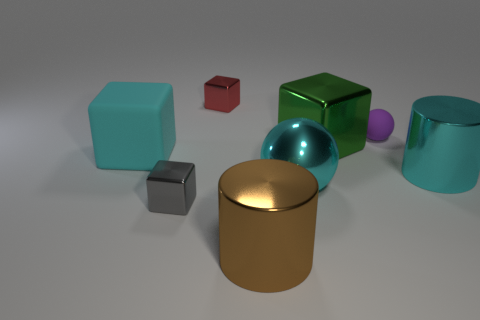What number of metallic objects are either big spheres or brown cylinders?
Ensure brevity in your answer.  2. Does the gray thing have the same material as the cyan sphere?
Ensure brevity in your answer.  Yes. What material is the large cube in front of the metal cube that is right of the red block?
Ensure brevity in your answer.  Rubber. How many big things are cyan cylinders or cyan balls?
Your answer should be compact. 2. The gray metallic thing has what size?
Offer a very short reply. Small. Is the number of cylinders behind the big cyan matte object greater than the number of tiny spheres?
Keep it short and to the point. No. Is the number of things in front of the large metal block the same as the number of cyan metallic cylinders on the left side of the small gray object?
Ensure brevity in your answer.  No. There is a block that is on the left side of the big brown metallic object and on the right side of the tiny gray object; what is its color?
Give a very brief answer. Red. Is there any other thing that has the same size as the cyan cylinder?
Your answer should be very brief. Yes. Is the number of small purple balls that are behind the rubber sphere greater than the number of small matte spheres behind the tiny red block?
Your answer should be very brief. No. 